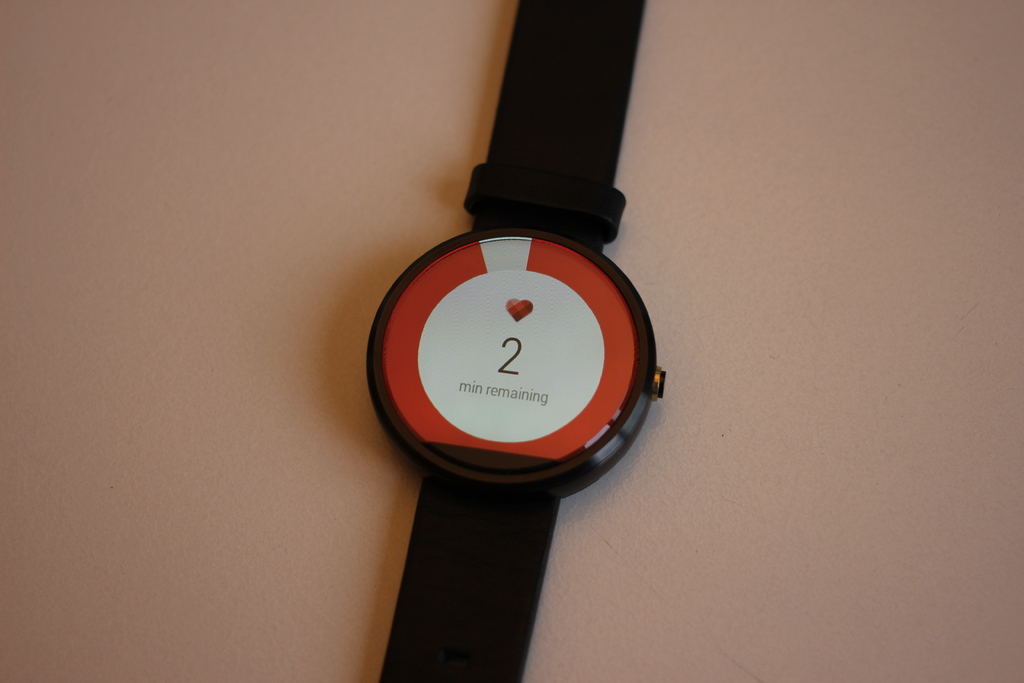Provide a one-sentence caption for the provided image. An elegant smartwatch displaying a heart symbol and indicating two minutes remaining, set against a simple background, highlighting its stylish, modern design. 